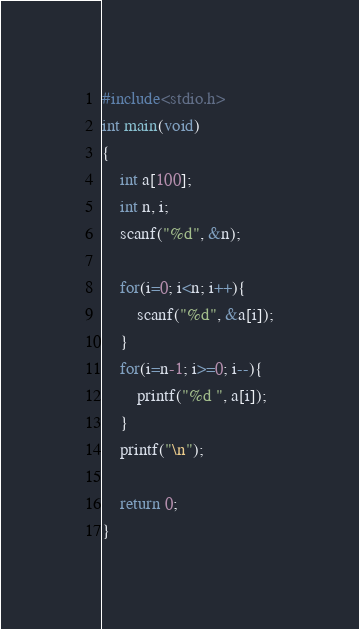Convert code to text. <code><loc_0><loc_0><loc_500><loc_500><_C_>#include<stdio.h>
int main(void)
{
	int a[100];
	int n, i;
	scanf("%d", &n);
	
	for(i=0; i<n; i++){
		scanf("%d", &a[i]);
	}
	for(i=n-1; i>=0; i--){
		printf("%d ", a[i]);
	}
	printf("\n");
	
	return 0;
}</code> 